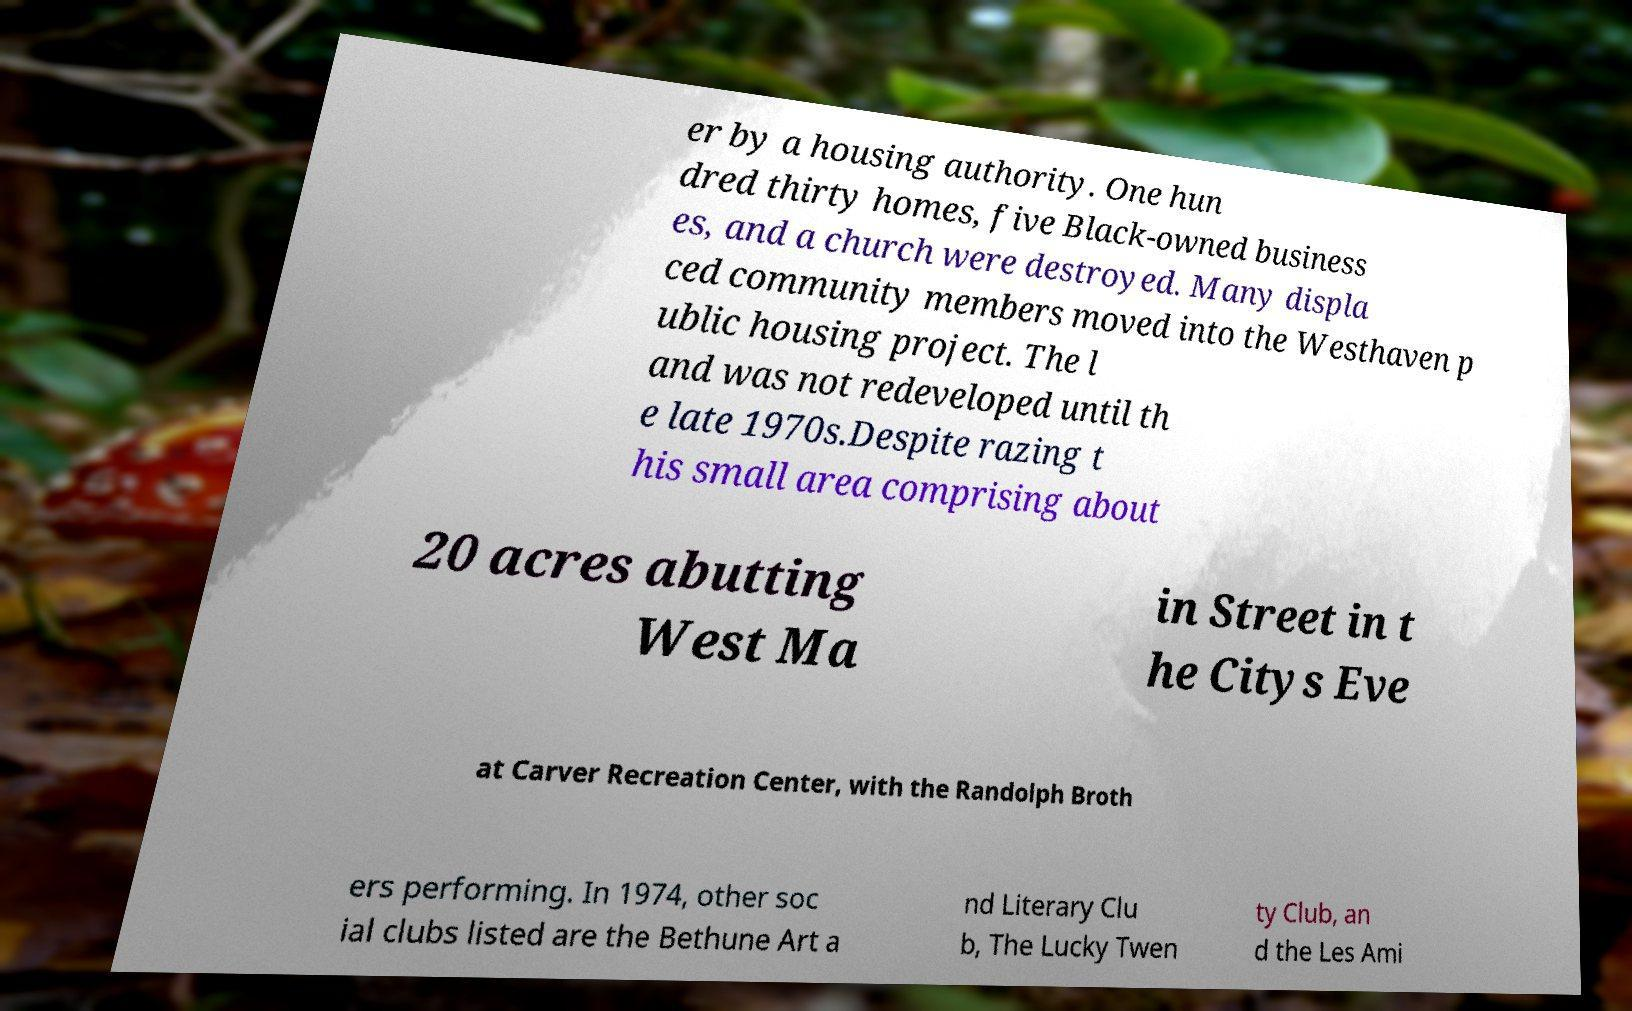Please read and relay the text visible in this image. What does it say? er by a housing authority. One hun dred thirty homes, five Black-owned business es, and a church were destroyed. Many displa ced community members moved into the Westhaven p ublic housing project. The l and was not redeveloped until th e late 1970s.Despite razing t his small area comprising about 20 acres abutting West Ma in Street in t he Citys Eve at Carver Recreation Center, with the Randolph Broth ers performing. In 1974, other soc ial clubs listed are the Bethune Art a nd Literary Clu b, The Lucky Twen ty Club, an d the Les Ami 